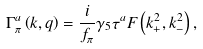Convert formula to latex. <formula><loc_0><loc_0><loc_500><loc_500>\Gamma _ { \pi } ^ { a } \left ( k , q \right ) = \frac { i } { f _ { \pi } } \gamma _ { 5 } \tau ^ { a } F \left ( k _ { + } ^ { 2 } , k _ { - } ^ { 2 } \right ) ,</formula> 